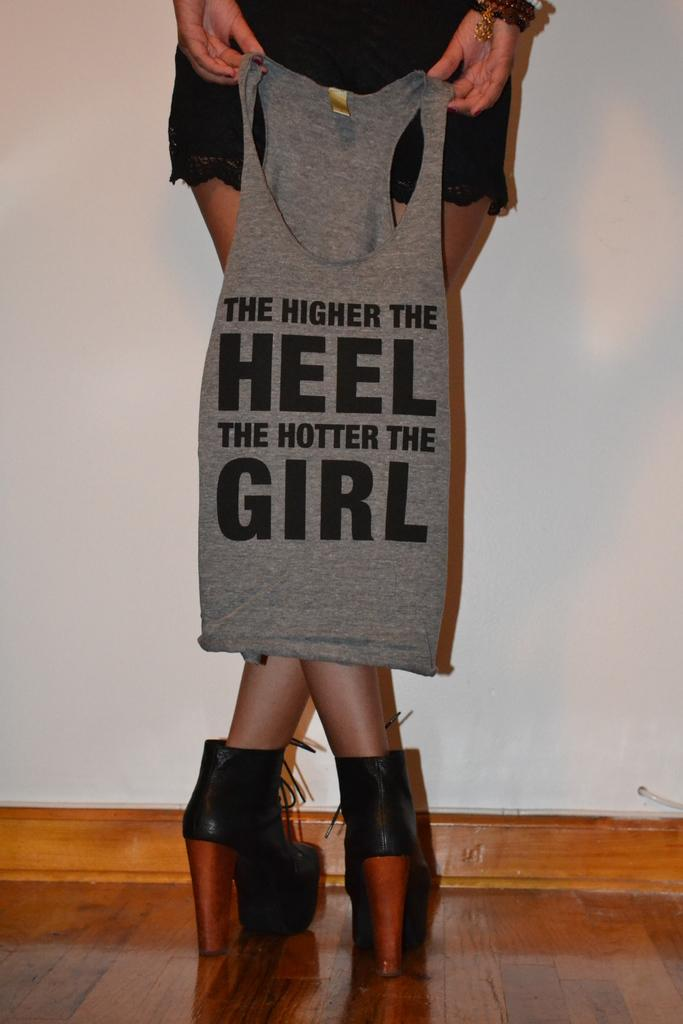Who is the main subject in the image? There is a lady in the image. What is the lady doing in the image? The lady is standing in the image. What is the lady holding in her hand? The lady is holding a T-shirt in her hand. What can be seen in the background of the image? There is a wall in the background of the image. What type of chess piece is the lady holding in the image? There is no chess piece present in the image; the lady is holding a T-shirt. 